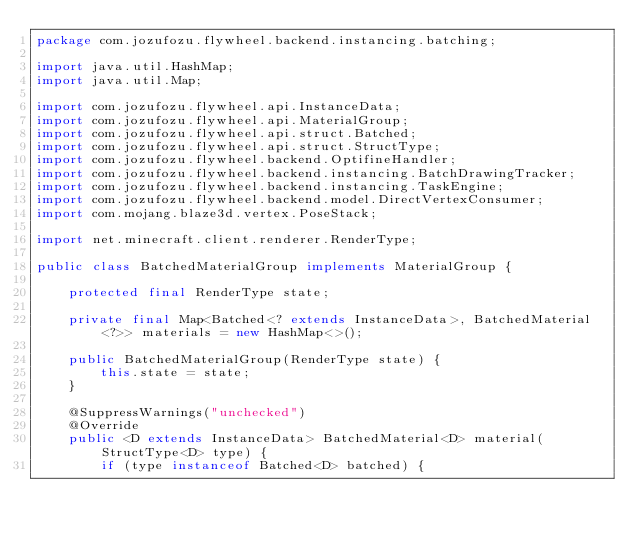<code> <loc_0><loc_0><loc_500><loc_500><_Java_>package com.jozufozu.flywheel.backend.instancing.batching;

import java.util.HashMap;
import java.util.Map;

import com.jozufozu.flywheel.api.InstanceData;
import com.jozufozu.flywheel.api.MaterialGroup;
import com.jozufozu.flywheel.api.struct.Batched;
import com.jozufozu.flywheel.api.struct.StructType;
import com.jozufozu.flywheel.backend.OptifineHandler;
import com.jozufozu.flywheel.backend.instancing.BatchDrawingTracker;
import com.jozufozu.flywheel.backend.instancing.TaskEngine;
import com.jozufozu.flywheel.backend.model.DirectVertexConsumer;
import com.mojang.blaze3d.vertex.PoseStack;

import net.minecraft.client.renderer.RenderType;

public class BatchedMaterialGroup implements MaterialGroup {

	protected final RenderType state;

	private final Map<Batched<? extends InstanceData>, BatchedMaterial<?>> materials = new HashMap<>();

	public BatchedMaterialGroup(RenderType state) {
		this.state = state;
	}

	@SuppressWarnings("unchecked")
	@Override
	public <D extends InstanceData> BatchedMaterial<D> material(StructType<D> type) {
		if (type instanceof Batched<D> batched) {</code> 